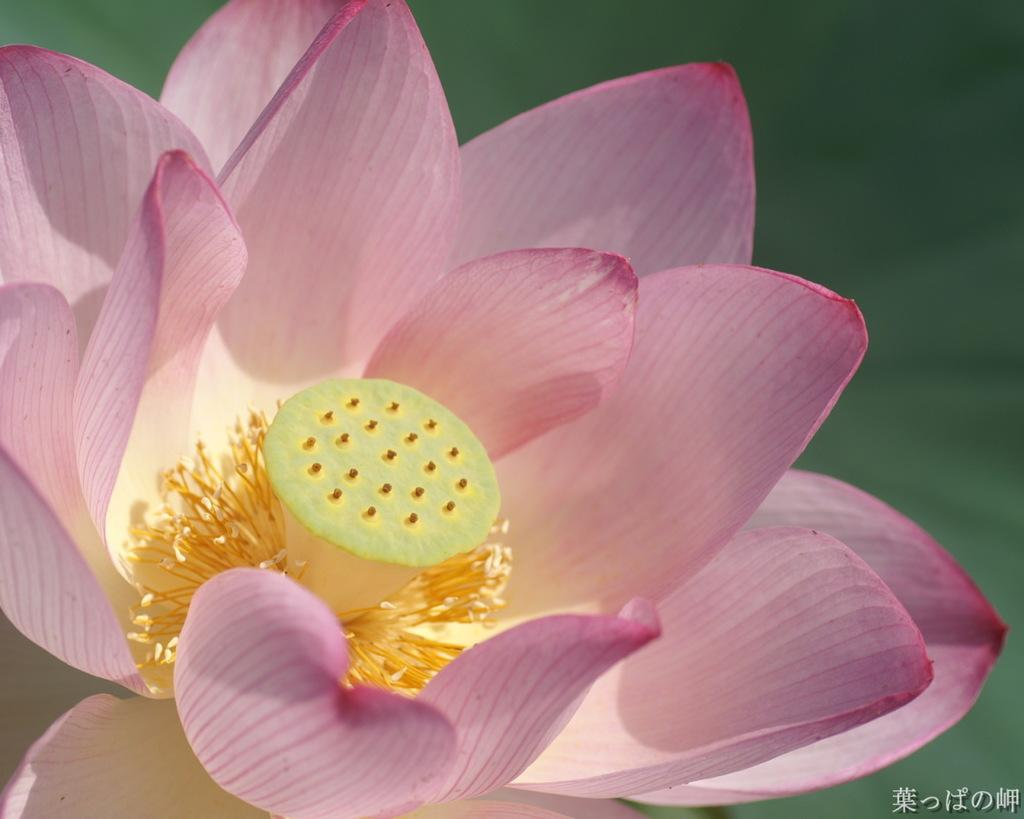What is the main subject of the picture? There is a flower in the picture. Can you describe the background of the image? The background of the image is blurred. How many leaves can be seen on the flower in the image? There is no mention of leaves on the flower in the provided facts, so it cannot be determined from the image. 